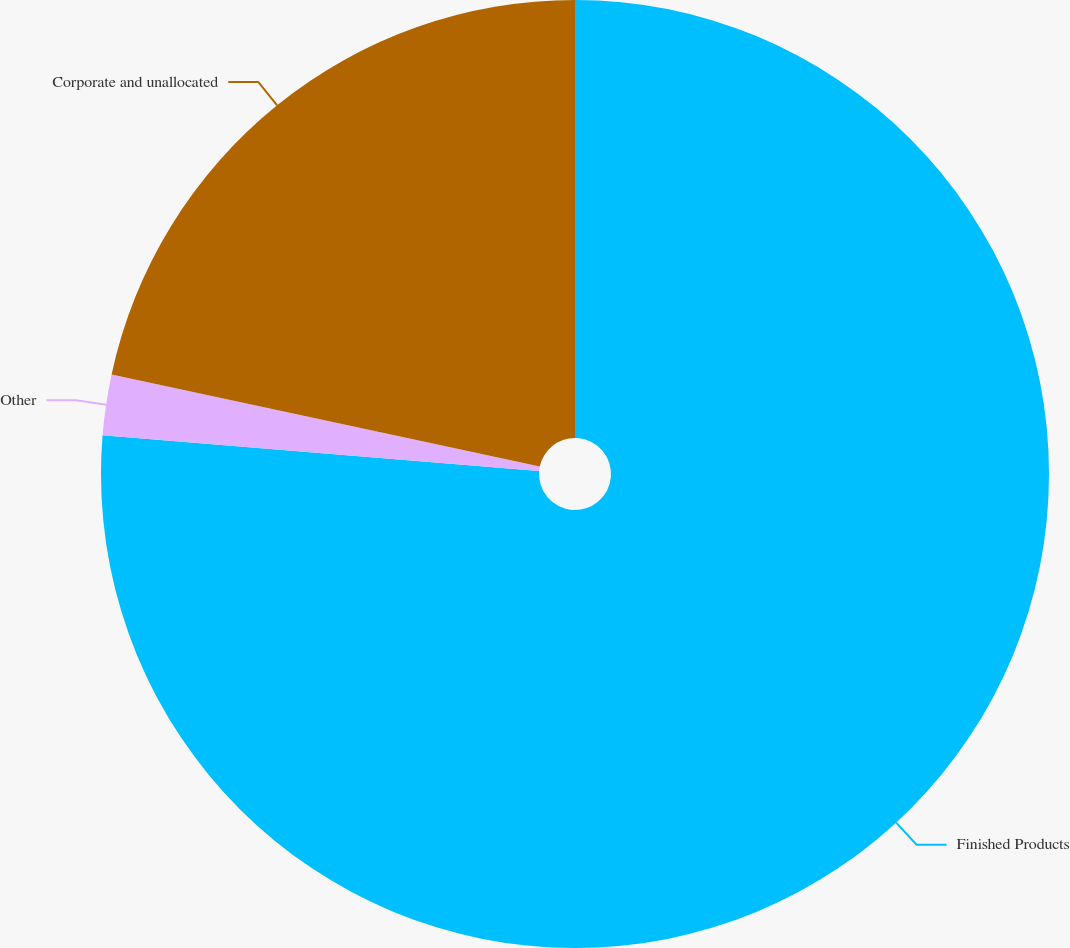<chart> <loc_0><loc_0><loc_500><loc_500><pie_chart><fcel>Finished Products<fcel>Other<fcel>Corporate and unallocated<nl><fcel>76.3%<fcel>2.07%<fcel>21.63%<nl></chart> 